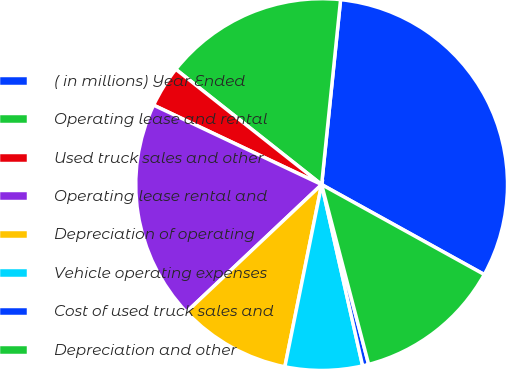Convert chart. <chart><loc_0><loc_0><loc_500><loc_500><pie_chart><fcel>( in millions) Year Ended<fcel>Operating lease and rental<fcel>Used truck sales and other<fcel>Operating lease rental and<fcel>Depreciation of operating<fcel>Vehicle operating expenses<fcel>Cost of used truck sales and<fcel>Depreciation and other<nl><fcel>31.42%<fcel>15.98%<fcel>3.62%<fcel>19.06%<fcel>9.8%<fcel>6.71%<fcel>0.53%<fcel>12.89%<nl></chart> 